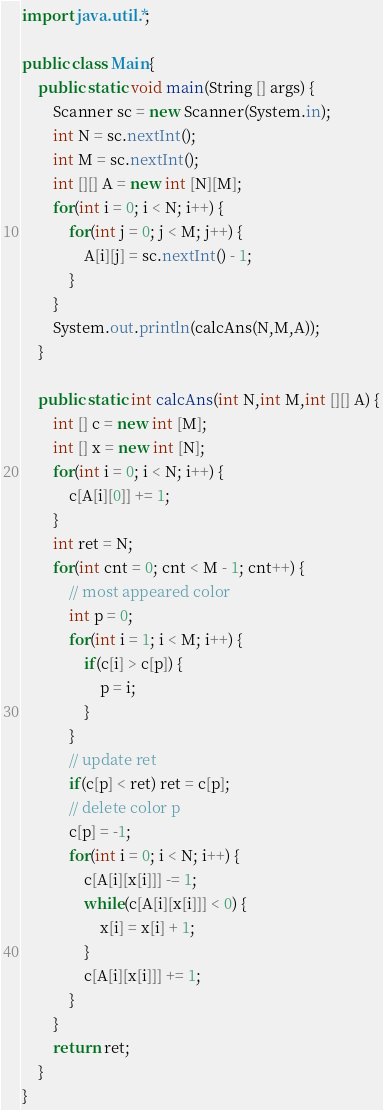<code> <loc_0><loc_0><loc_500><loc_500><_Java_>import java.util.*;

public class Main{
    public static void main(String [] args) {
        Scanner sc = new Scanner(System.in);
        int N = sc.nextInt();
        int M = sc.nextInt();
        int [][] A = new int [N][M];
        for(int i = 0; i < N; i++) {
            for(int j = 0; j < M; j++) {
                A[i][j] = sc.nextInt() - 1;
            }
        }
        System.out.println(calcAns(N,M,A));
    }

    public static int calcAns(int N,int M,int [][] A) {
        int [] c = new int [M];
        int [] x = new int [N];
        for(int i = 0; i < N; i++) {
            c[A[i][0]] += 1;
        }
        int ret = N;
        for(int cnt = 0; cnt < M - 1; cnt++) {
            // most appeared color
            int p = 0;
            for(int i = 1; i < M; i++) {
                if(c[i] > c[p]) {
                    p = i;
                }
            }
            // update ret
            if(c[p] < ret) ret = c[p];
            // delete color p
            c[p] = -1;
            for(int i = 0; i < N; i++) {
                c[A[i][x[i]]] -= 1;
                while(c[A[i][x[i]]] < 0) {
                    x[i] = x[i] + 1;
                }
                c[A[i][x[i]]] += 1;
            }
        }
        return ret;
    }
}
</code> 